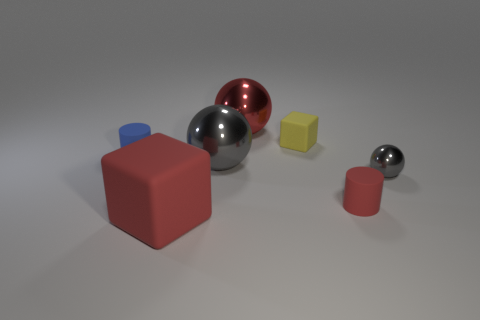Are there any other things that are made of the same material as the small gray object?
Give a very brief answer. Yes. Is the number of matte cubes to the left of the small blue cylinder less than the number of big red spheres in front of the big gray shiny thing?
Give a very brief answer. No. Are there any other things that have the same color as the big block?
Ensure brevity in your answer.  Yes. The yellow object has what shape?
Your response must be concise. Cube. There is another large thing that is the same material as the yellow thing; what color is it?
Ensure brevity in your answer.  Red. Is the number of purple matte cubes greater than the number of small blue things?
Provide a short and direct response. No. Are any big gray shiny spheres visible?
Keep it short and to the point. Yes. The gray object on the right side of the tiny cylinder on the right side of the small blue matte thing is what shape?
Offer a terse response. Sphere. How many things are matte objects or large objects that are in front of the tiny yellow block?
Give a very brief answer. 5. What is the color of the cube that is in front of the red rubber thing on the right side of the big red object behind the red cylinder?
Offer a very short reply. Red. 